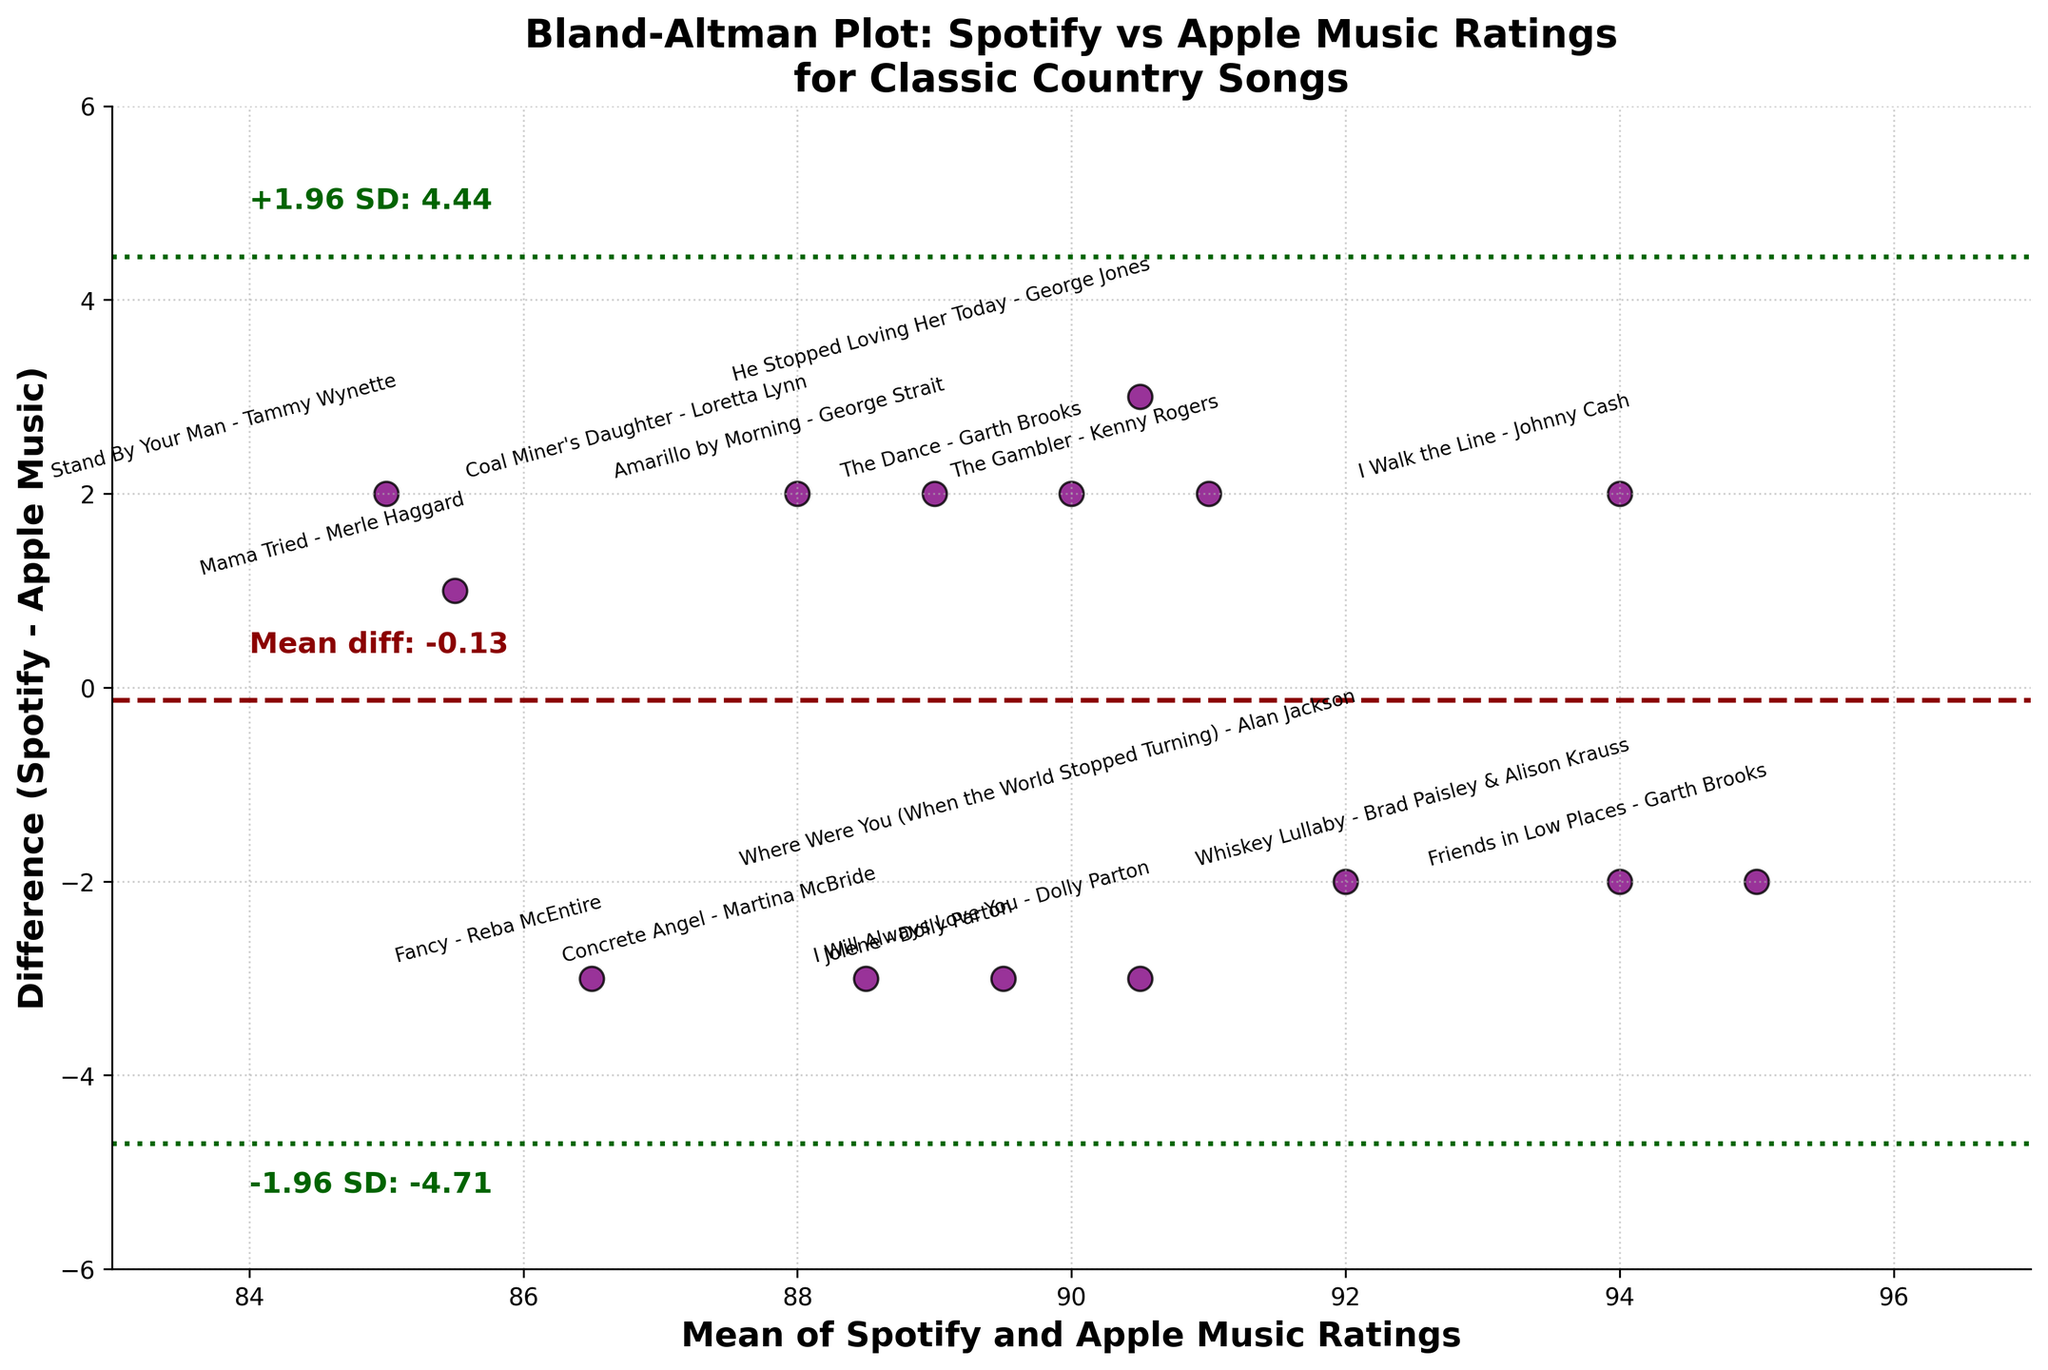what is the mean difference between Spotify and Apple Music ratings? The mean difference is displayed as a horizontal dashed dark red line on the plot. It is labeled as 'Mean diff: -0.87', indicating the average difference between the ratings from Spotify and Apple Music. So the mean difference is -0.87.
Answer: -0.87 How many songs have a higher rating on Apple Music compared to Spotify? To determine this, look for the points below zero on the y-axis (negative difference values). Counting these points gives us six such songs where Apple Music has higher ratings compared to Spotify.
Answer: 6 Which song has the highest difference in ratings between Spotify and Apple Music? The largest difference is marked by the furthest point from zero on the y-axis. "Jolene" by Dolly Parton shows the highest difference with a value around -3.
Answer: "Jolene" by Dolly Parton What are the upper and lower limits of agreement? The upper and lower limits of agreement are marked by the dotted dark green lines. The annotations indicate '+1.96 SD: 1.34' for the upper limit and '-1.96 SD: -3.08' for the lower limit. So the values are 1.34 and -3.08 respectively.
Answer: 1.34 and -3.08 Do most of the songs fall within the limits of agreement? Most of the points (songs) are between the upper limit of 1.34 and the lower limit of -3.08, indicating that the majority of the song ratings fall within these limits of agreement, which suggests consistency between the two platforms.
Answer: Yes What is the range of the mean ratings from both platforms? The x-axis represents the mean of Spotify and Apple Music ratings. The plot spans from approximately 83 to 97 on this axis.
Answer: 83 to 97 Which song has higher Spotify rating but almost equal Apple Music rating with "He Stopped Loving Her Today"? By comparing the mean differences and looking for annotations, "The Gambler" by Kenny Rogers appears to have a similar range in mean ratings but with a higher Spotify rating.
Answer: "The Gambler" by Kenny Rogers Is there a song where Spotify and Apple Music ratings are exactly the same? If there were, the difference would be zero and it would lie exactly on the horizontal line at the zero on the y-axis. There are no points on this zero line, indicating that no song has exactly the same rating on both platforms.
Answer: No Which song has the least difference in ratings between Spotify and Apple Music? The song with the nearest point to zero difference on the y-axis represents the least difference in ratings. "Stand By Your Man" by Tammy Wynette is closest to zero showing nearly identical ratings on both platforms.
Answer: "Stand By Your Man" by Tammy Wynette 